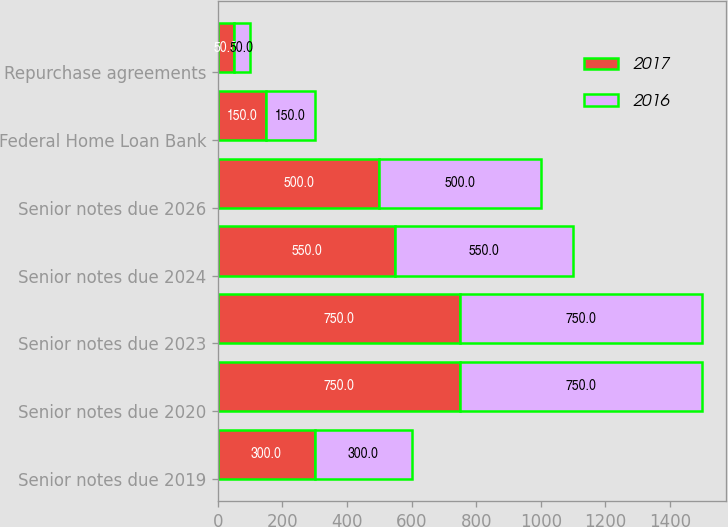Convert chart to OTSL. <chart><loc_0><loc_0><loc_500><loc_500><stacked_bar_chart><ecel><fcel>Senior notes due 2019<fcel>Senior notes due 2020<fcel>Senior notes due 2023<fcel>Senior notes due 2024<fcel>Senior notes due 2026<fcel>Federal Home Loan Bank<fcel>Repurchase agreements<nl><fcel>2017<fcel>300<fcel>750<fcel>750<fcel>550<fcel>500<fcel>150<fcel>50<nl><fcel>2016<fcel>300<fcel>750<fcel>750<fcel>550<fcel>500<fcel>150<fcel>50<nl></chart> 